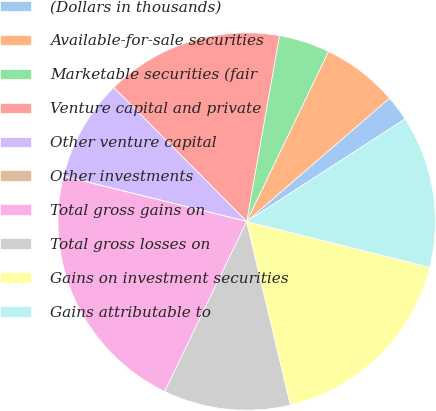Convert chart to OTSL. <chart><loc_0><loc_0><loc_500><loc_500><pie_chart><fcel>(Dollars in thousands)<fcel>Available-for-sale securities<fcel>Marketable securities (fair<fcel>Venture capital and private<fcel>Other venture capital<fcel>Other investments<fcel>Total gross gains on<fcel>Total gross losses on<fcel>Gains on investment securities<fcel>Gains attributable to<nl><fcel>2.19%<fcel>6.53%<fcel>4.36%<fcel>15.21%<fcel>8.7%<fcel>0.02%<fcel>21.71%<fcel>10.87%<fcel>17.38%<fcel>13.04%<nl></chart> 